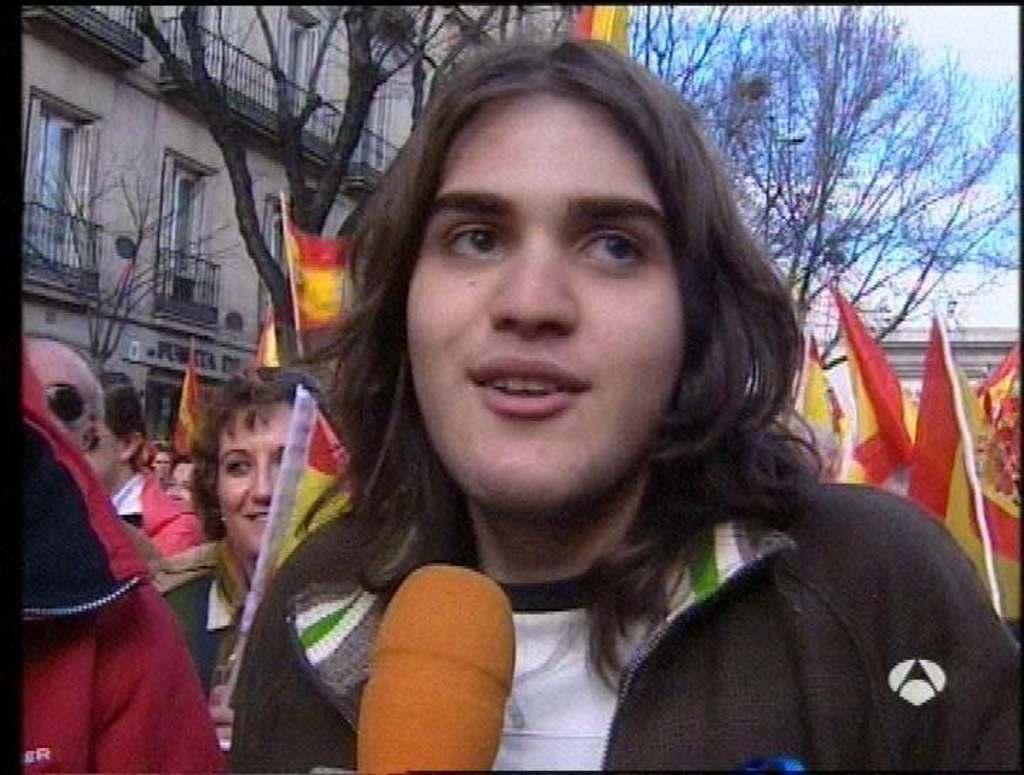Can you describe this image briefly? In this image we can see some group of persons standing and holding some flags in their hands and in the foreground of the image there is a person standing behind the microphone and in the background of the image there are some trees and buildings. 